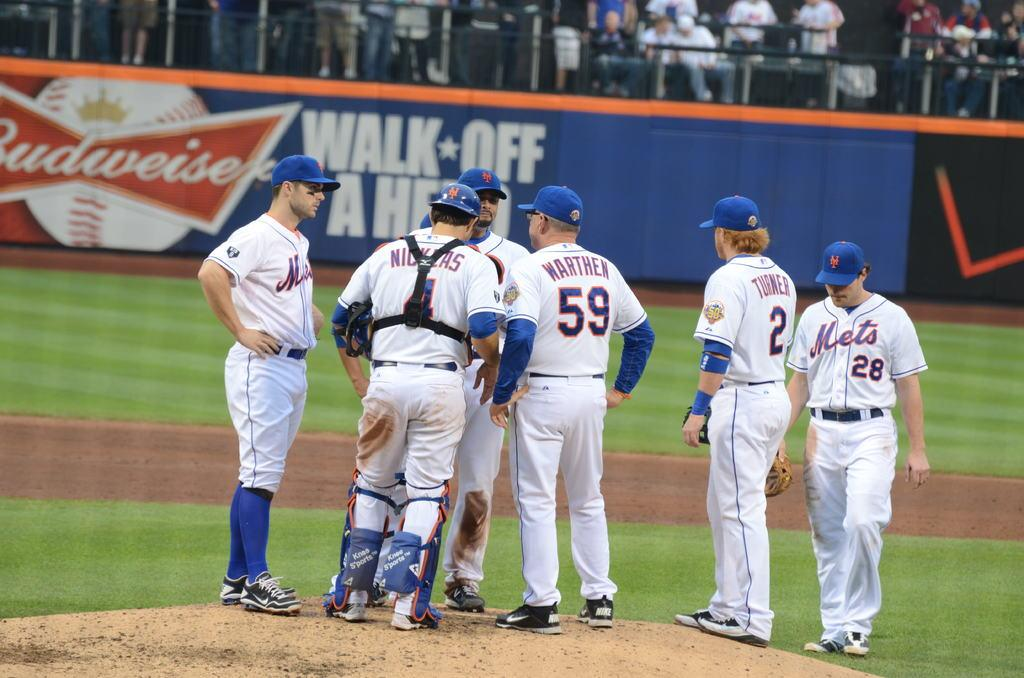<image>
Present a compact description of the photo's key features. a baseball fence with the words walk off a hero on it 